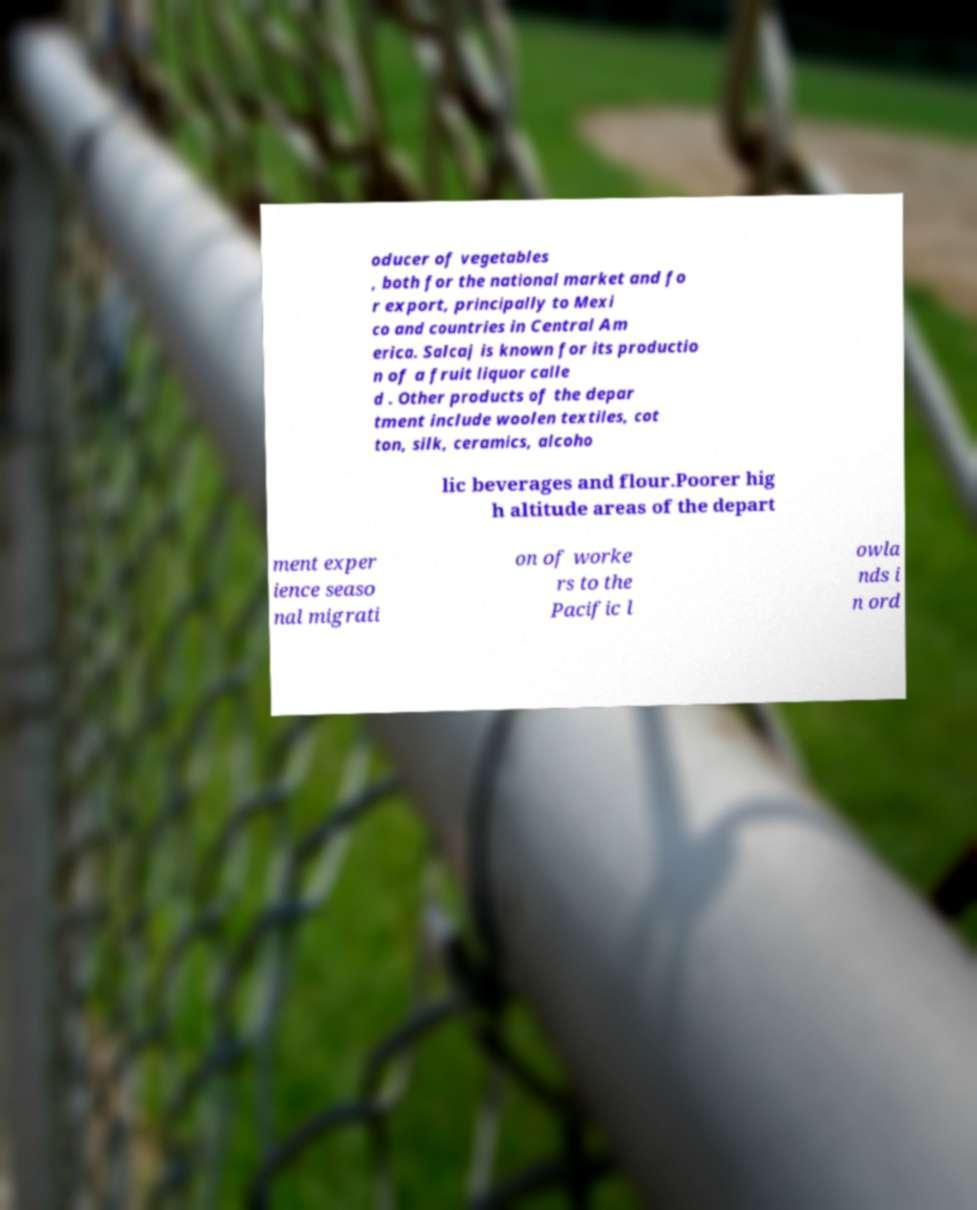Can you read and provide the text displayed in the image?This photo seems to have some interesting text. Can you extract and type it out for me? oducer of vegetables , both for the national market and fo r export, principally to Mexi co and countries in Central Am erica. Salcaj is known for its productio n of a fruit liquor calle d . Other products of the depar tment include woolen textiles, cot ton, silk, ceramics, alcoho lic beverages and flour.Poorer hig h altitude areas of the depart ment exper ience seaso nal migrati on of worke rs to the Pacific l owla nds i n ord 